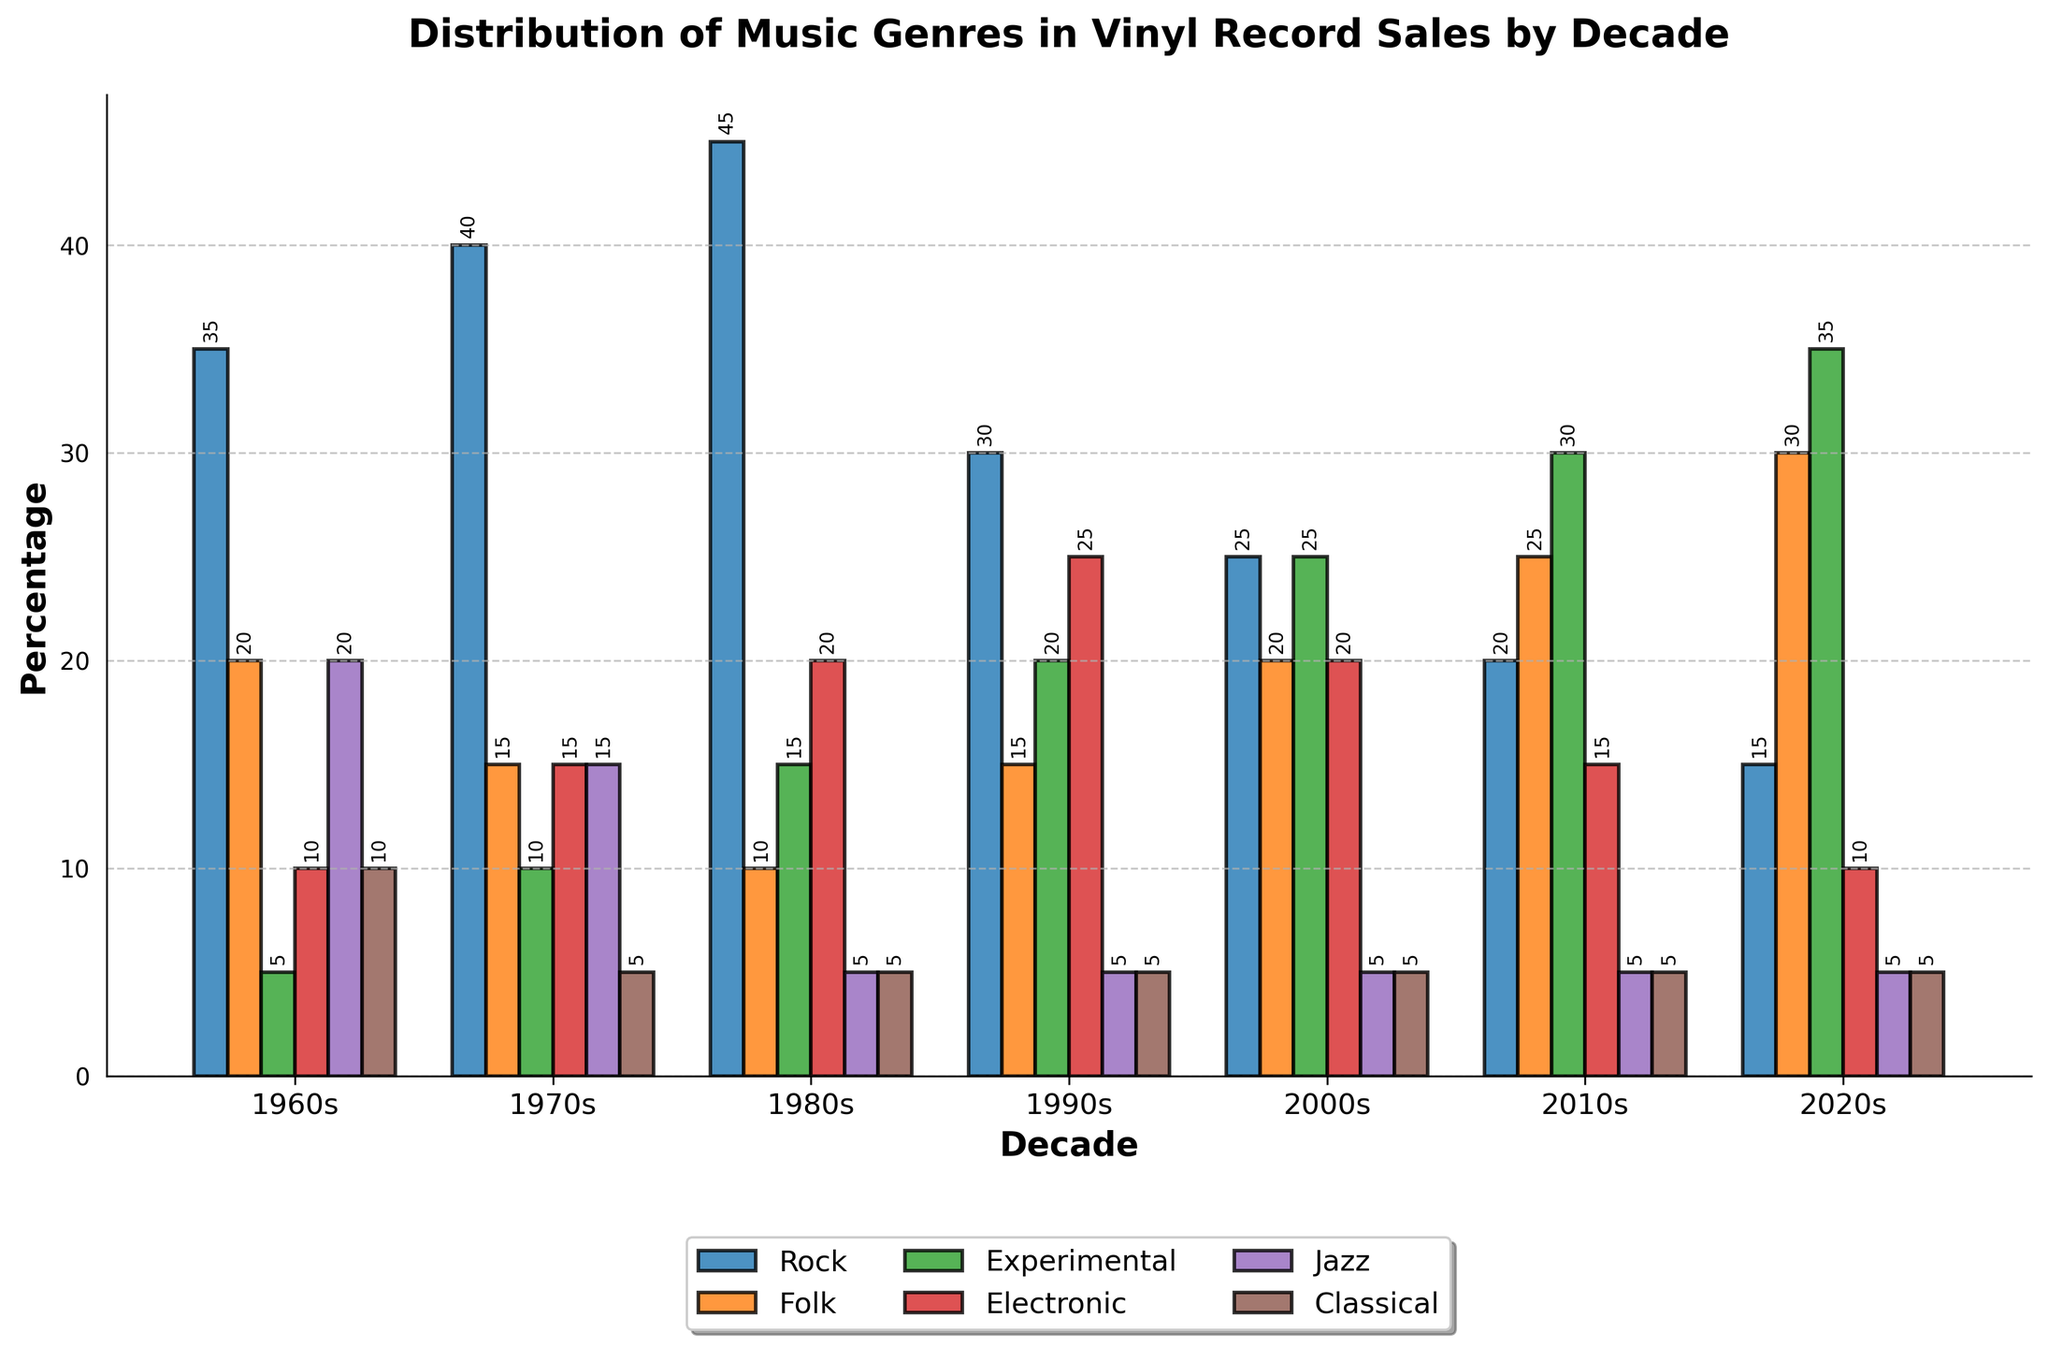What is the most popular genre in the 1970s? From the chart, the highest bar in the 1970s decade category indicates the most popular genre. The Rock genre has the tallest bar.
Answer: Rock How did the popularity of Electronic music change from the 1960s to the 2020s? The bar for Electronic music starts at 10% in the 1960s and fluctuates but ultimately slightly decreases to 10% in the 2020s.
Answer: No significant change Which decade saw the highest percentage of Experimental music sales? By looking at the heights of the bars for the Experimental genre across all decades, the highest bar appears in the 2020s.
Answer: 2020s In which decade was Folk music more popular: the 1960s or the 1980s? The height of the Folk genre bar in the 1960s is higher than that in the 1980s.
Answer: 1960s What is the average percentage of Jazz sales from the 1960s to the 2020s? Add the percentages of Jazz sales for each decade: (20 + 15 + 5 + 5 + 5 + 5 + 5) = 60. Divide by the number of decades (7): 60/7 ≈ 8.57
Answer: 8.57% Compare the popularity of Classical music in the 1970s and the 2010s. The height of the Classical genre bar in the 1970s is slightly higher than that in the 2010s, which are 5% and 5% respectively.
Answer: Equal Which genre experienced consistent growth in the percentage of sales from the 1960s to the 2020s? The Experimental genre's bar heights show a consistent growth from the 1960s (5%) to the 2020s (35%).
Answer: Experimental What was the total percentage of sales for Rock and Electronic music combined in the 1980s? Add the percentages for Rock and Electronic: 45% (Rock) + 20% (Electronic) = 65%.
Answer: 65% Which genre had the least percentage of sales in the 1960s, and how does this compare to the same genre in the 2020s? Experimental had the least percentage of sales in the 1960s (5%), and in the 2020s, it increased to 35%.
Answer: Experimental, increased Between the 2000s and 2010s, which genre showed the most growth in percentage? Subtract the percentages of each genre for the two decades and find the maximum difference. Experimental music grew from 25% in the 2000s to 30% in the 2010s, which is a growth of 5%. No other genre grew as much.
Answer: Experimental, 5% 